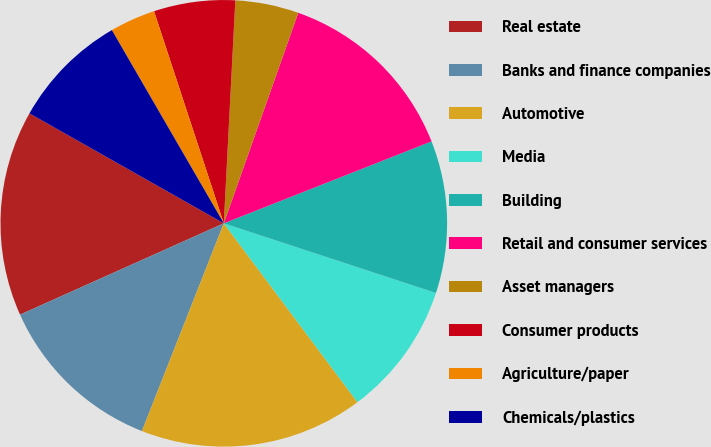Convert chart to OTSL. <chart><loc_0><loc_0><loc_500><loc_500><pie_chart><fcel>Real estate<fcel>Banks and finance companies<fcel>Automotive<fcel>Media<fcel>Building<fcel>Retail and consumer services<fcel>Asset managers<fcel>Consumer products<fcel>Agriculture/paper<fcel>Chemicals/plastics<nl><fcel>14.9%<fcel>12.32%<fcel>16.19%<fcel>9.74%<fcel>11.03%<fcel>13.61%<fcel>4.59%<fcel>5.88%<fcel>3.3%<fcel>8.45%<nl></chart> 